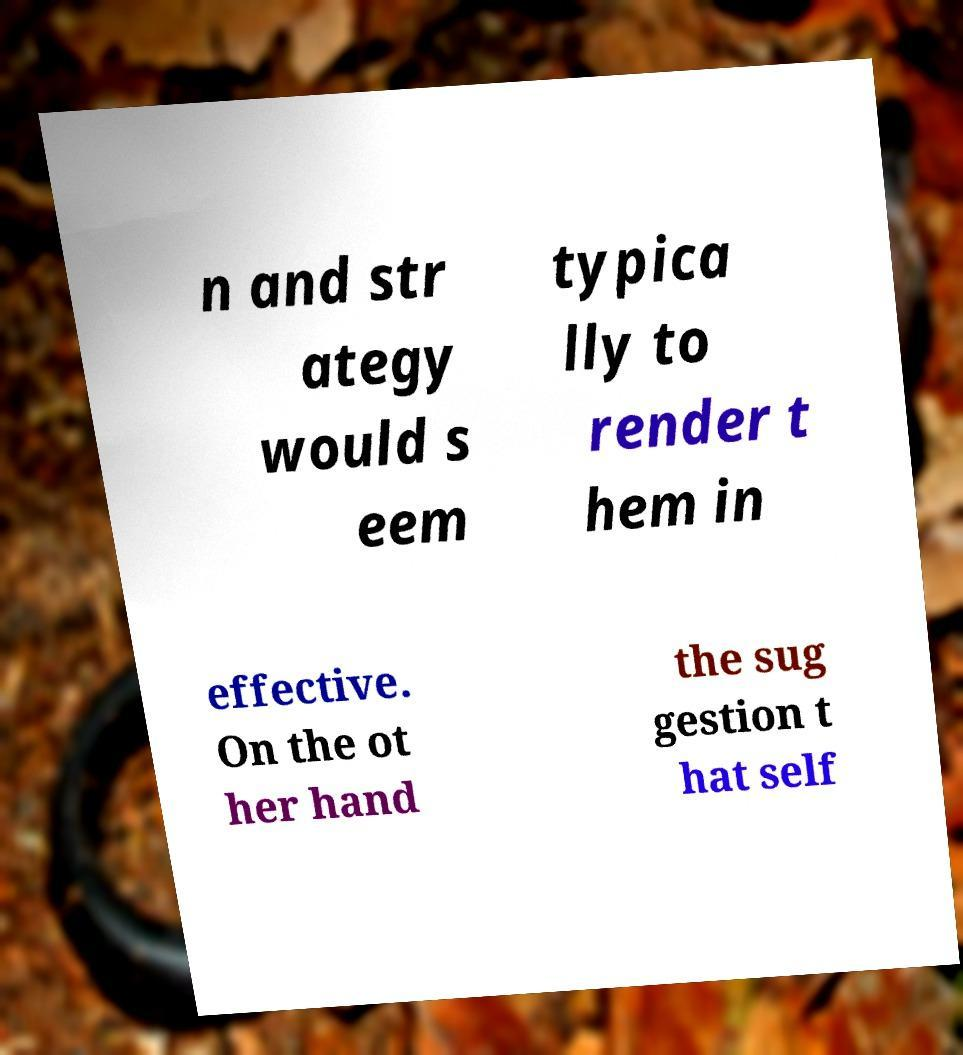There's text embedded in this image that I need extracted. Can you transcribe it verbatim? n and str ategy would s eem typica lly to render t hem in effective. On the ot her hand the sug gestion t hat self 